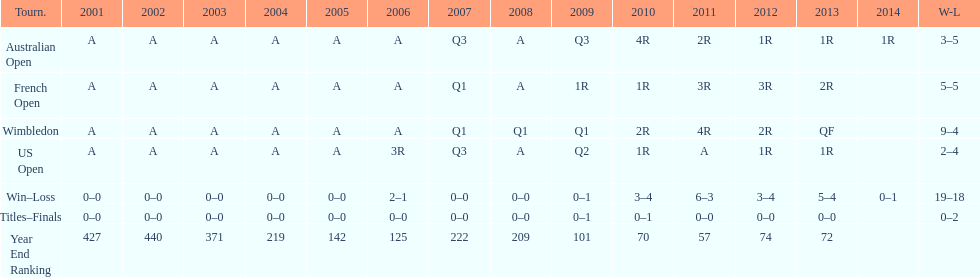What was this players ranking after 2005? 125. 